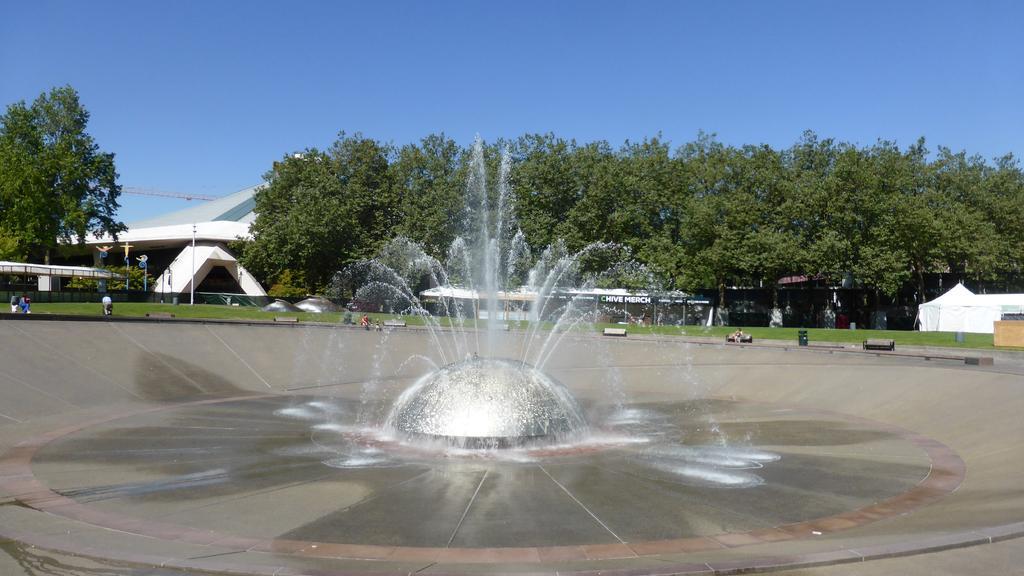How would you summarize this image in a sentence or two? In this picture I can see there is a fountain here and I can see there are few people sitting here in the benches and in the backdrop there is a building and there are trees and the sky is clear. 